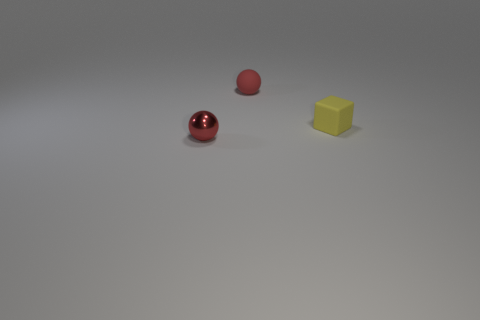Do the small rubber sphere and the small metallic ball have the same color?
Give a very brief answer. Yes. What shape is the thing that is the same color as the small metal sphere?
Provide a succinct answer. Sphere. Is the color of the small shiny object the same as the small ball behind the red metal thing?
Give a very brief answer. Yes. There is a red metallic object that is the same size as the yellow cube; what shape is it?
Ensure brevity in your answer.  Sphere. Is there a metallic object of the same shape as the red matte thing?
Make the answer very short. Yes. What number of balls are the same material as the yellow cube?
Provide a short and direct response. 1. Does the small ball in front of the small yellow object have the same material as the tiny yellow cube?
Give a very brief answer. No. Are there more tiny red objects to the left of the yellow matte object than tiny spheres that are to the left of the tiny red matte thing?
Make the answer very short. Yes. What material is the sphere that is the same size as the red rubber object?
Your answer should be very brief. Metal. How many other things are the same material as the tiny yellow block?
Your answer should be very brief. 1. 